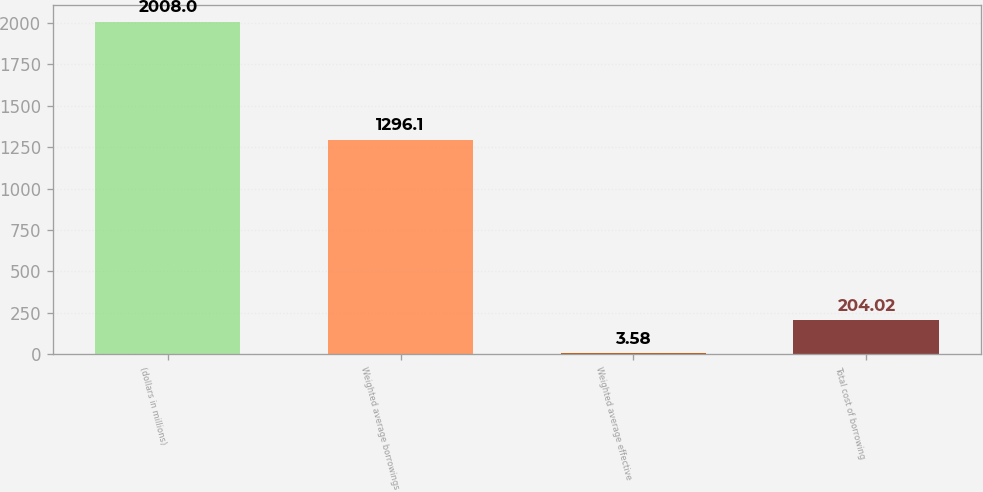<chart> <loc_0><loc_0><loc_500><loc_500><bar_chart><fcel>(dollars in millions)<fcel>Weighted average borrowings<fcel>Weighted average effective<fcel>Total cost of borrowing<nl><fcel>2008<fcel>1296.1<fcel>3.58<fcel>204.02<nl></chart> 